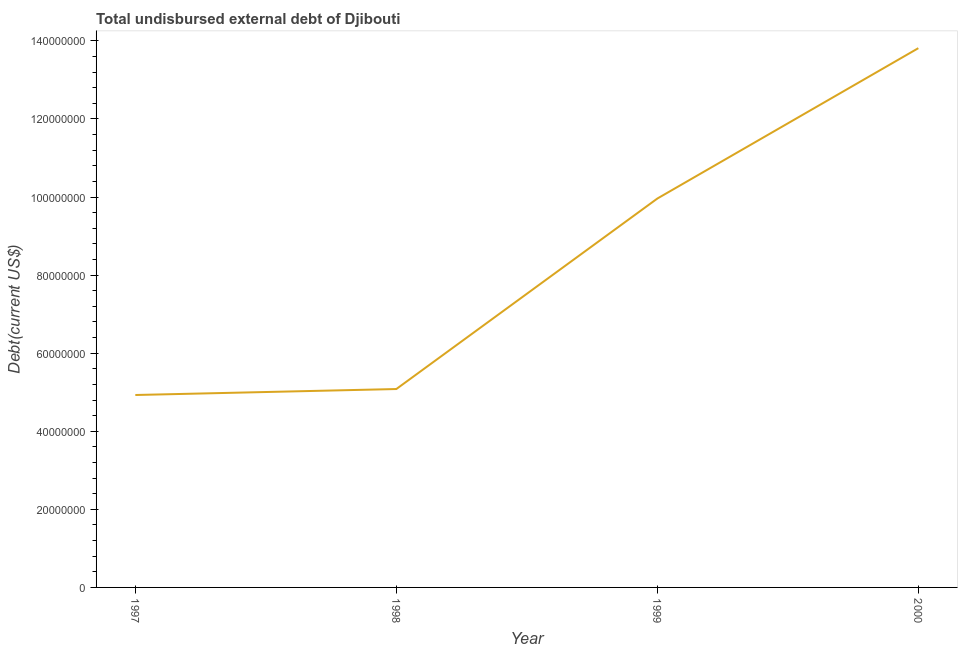What is the total debt in 1997?
Your answer should be very brief. 4.93e+07. Across all years, what is the maximum total debt?
Your answer should be compact. 1.38e+08. Across all years, what is the minimum total debt?
Provide a short and direct response. 4.93e+07. What is the sum of the total debt?
Your answer should be very brief. 3.38e+08. What is the difference between the total debt in 1999 and 2000?
Ensure brevity in your answer.  -3.85e+07. What is the average total debt per year?
Your response must be concise. 8.45e+07. What is the median total debt?
Your response must be concise. 7.52e+07. Do a majority of the years between 1998 and 1997 (inclusive) have total debt greater than 112000000 US$?
Your answer should be very brief. No. What is the ratio of the total debt in 1998 to that in 1999?
Provide a succinct answer. 0.51. Is the total debt in 1998 less than that in 1999?
Offer a terse response. Yes. What is the difference between the highest and the second highest total debt?
Provide a short and direct response. 3.85e+07. What is the difference between the highest and the lowest total debt?
Make the answer very short. 8.88e+07. Does the total debt monotonically increase over the years?
Offer a terse response. Yes. How many lines are there?
Ensure brevity in your answer.  1. What is the difference between two consecutive major ticks on the Y-axis?
Give a very brief answer. 2.00e+07. Does the graph contain grids?
Offer a terse response. No. What is the title of the graph?
Your answer should be compact. Total undisbursed external debt of Djibouti. What is the label or title of the Y-axis?
Your answer should be very brief. Debt(current US$). What is the Debt(current US$) of 1997?
Ensure brevity in your answer.  4.93e+07. What is the Debt(current US$) of 1998?
Provide a short and direct response. 5.08e+07. What is the Debt(current US$) of 1999?
Keep it short and to the point. 9.96e+07. What is the Debt(current US$) of 2000?
Offer a very short reply. 1.38e+08. What is the difference between the Debt(current US$) in 1997 and 1998?
Offer a very short reply. -1.53e+06. What is the difference between the Debt(current US$) in 1997 and 1999?
Give a very brief answer. -5.03e+07. What is the difference between the Debt(current US$) in 1997 and 2000?
Your answer should be compact. -8.88e+07. What is the difference between the Debt(current US$) in 1998 and 1999?
Provide a succinct answer. -4.88e+07. What is the difference between the Debt(current US$) in 1998 and 2000?
Keep it short and to the point. -8.73e+07. What is the difference between the Debt(current US$) in 1999 and 2000?
Provide a short and direct response. -3.85e+07. What is the ratio of the Debt(current US$) in 1997 to that in 1998?
Give a very brief answer. 0.97. What is the ratio of the Debt(current US$) in 1997 to that in 1999?
Offer a terse response. 0.49. What is the ratio of the Debt(current US$) in 1997 to that in 2000?
Offer a very short reply. 0.36. What is the ratio of the Debt(current US$) in 1998 to that in 1999?
Offer a very short reply. 0.51. What is the ratio of the Debt(current US$) in 1998 to that in 2000?
Make the answer very short. 0.37. What is the ratio of the Debt(current US$) in 1999 to that in 2000?
Offer a very short reply. 0.72. 